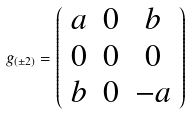<formula> <loc_0><loc_0><loc_500><loc_500>g _ { ( \pm 2 ) } = \left ( \begin{array} { c c c } a & 0 & b \\ 0 & 0 & 0 \\ b & 0 & - a \end{array} \right )</formula> 